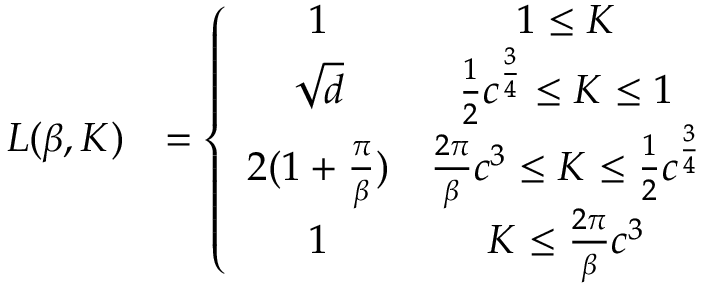<formula> <loc_0><loc_0><loc_500><loc_500>\begin{array} { r l } { L ( \beta , K ) } & { = \left \{ \begin{array} { c c } { 1 } & { 1 \leq K } \\ { \sqrt { d } } & { \frac { 1 } { 2 } c ^ { \frac { 3 } { 4 } } \leq K \leq 1 } \\ { 2 ( 1 + \frac { \pi } { \beta } ) } & { \frac { 2 \pi } \beta c ^ { 3 } \leq K \leq \frac { 1 } { 2 } c ^ { \frac { 3 } { 4 } } } \\ { 1 } & { K \leq \frac { 2 \pi } \beta c ^ { 3 } } \end{array} } \end{array}</formula> 